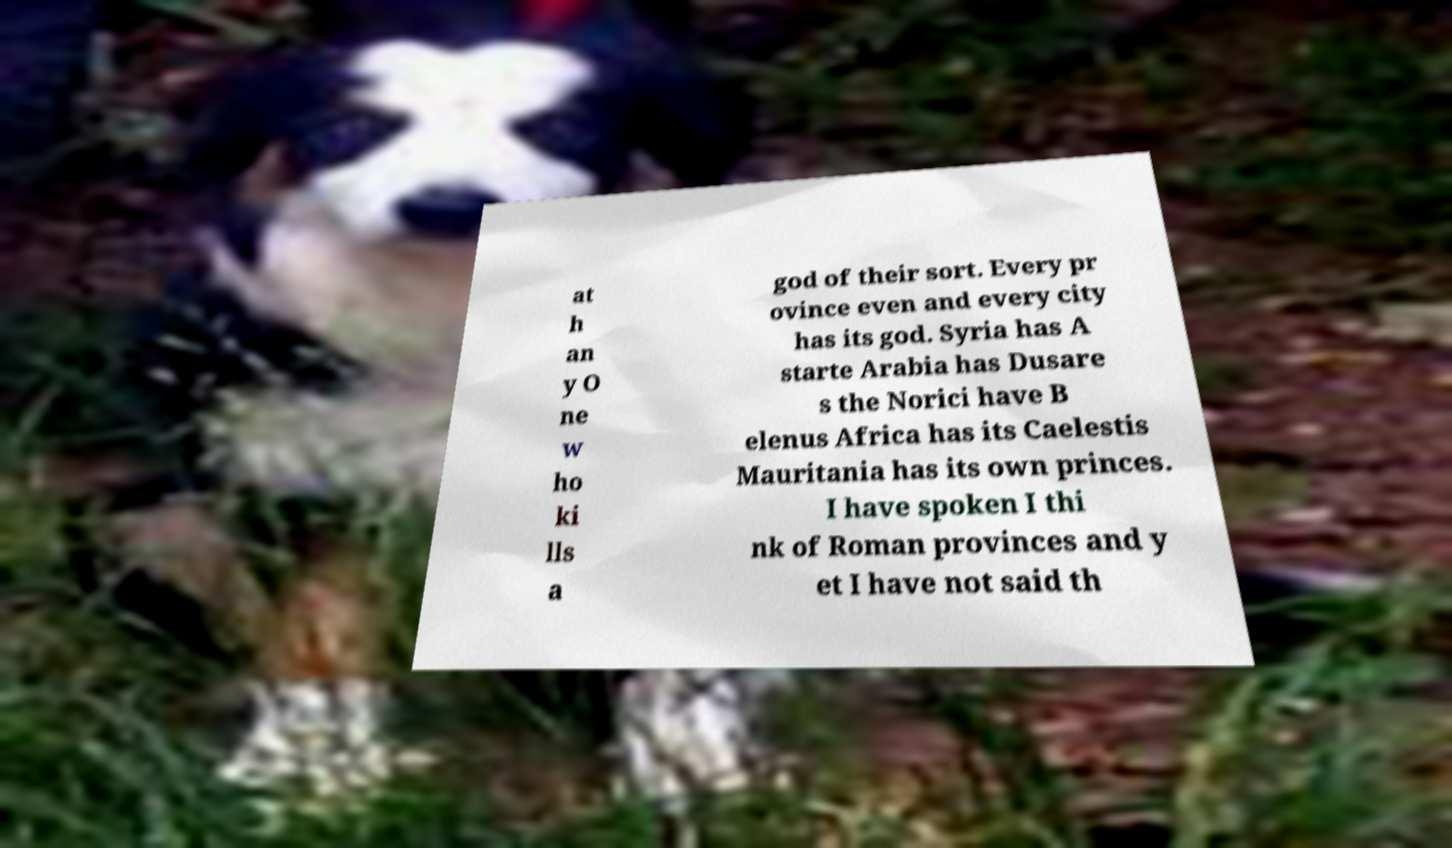Can you read and provide the text displayed in the image?This photo seems to have some interesting text. Can you extract and type it out for me? at h an y O ne w ho ki lls a god of their sort. Every pr ovince even and every city has its god. Syria has A starte Arabia has Dusare s the Norici have B elenus Africa has its Caelestis Mauritania has its own princes. I have spoken I thi nk of Roman provinces and y et I have not said th 